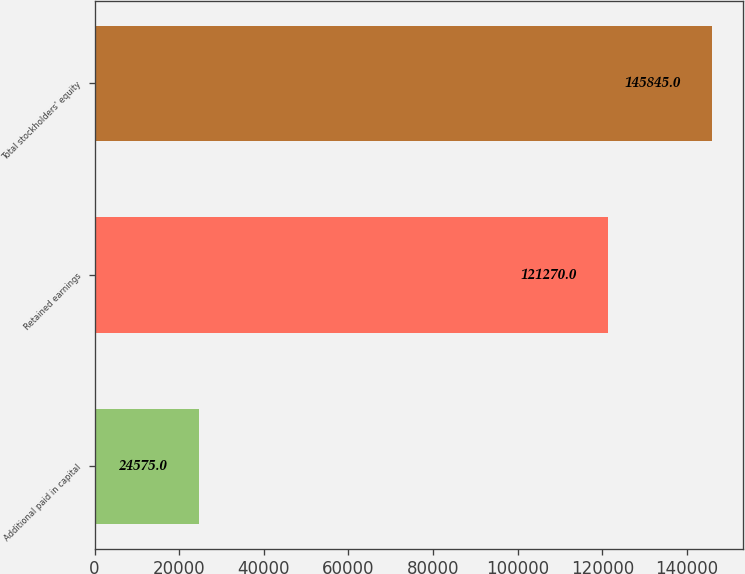<chart> <loc_0><loc_0><loc_500><loc_500><bar_chart><fcel>Additional paid in capital<fcel>Retained earnings<fcel>Total stockholders' equity<nl><fcel>24575<fcel>121270<fcel>145845<nl></chart> 